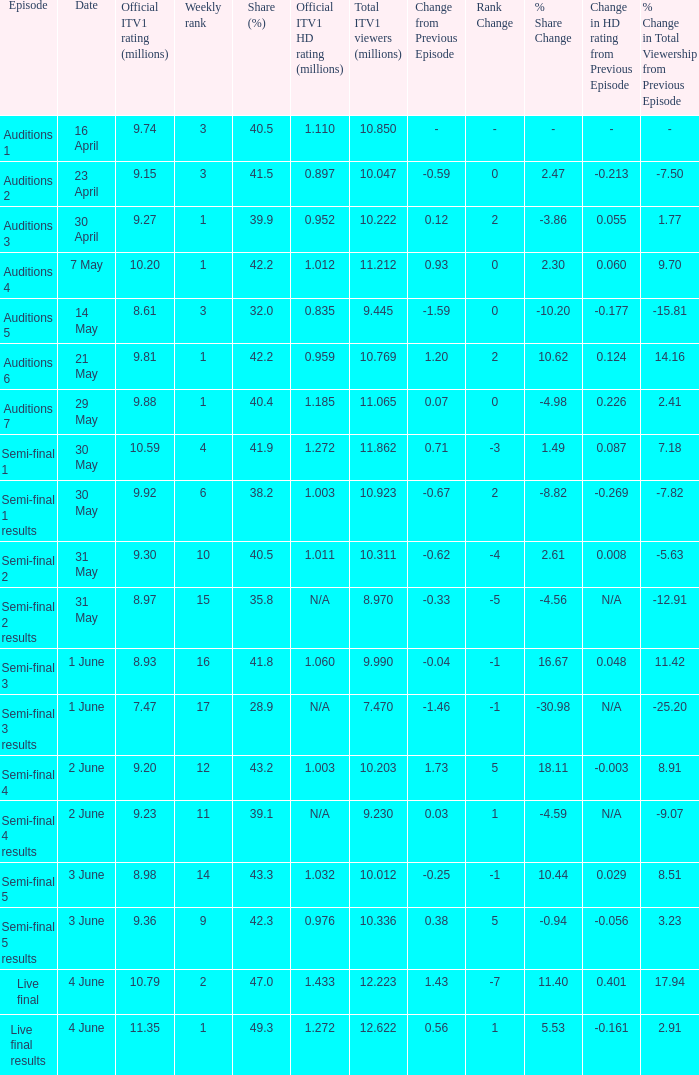When was the episode with a 4 23 April. 